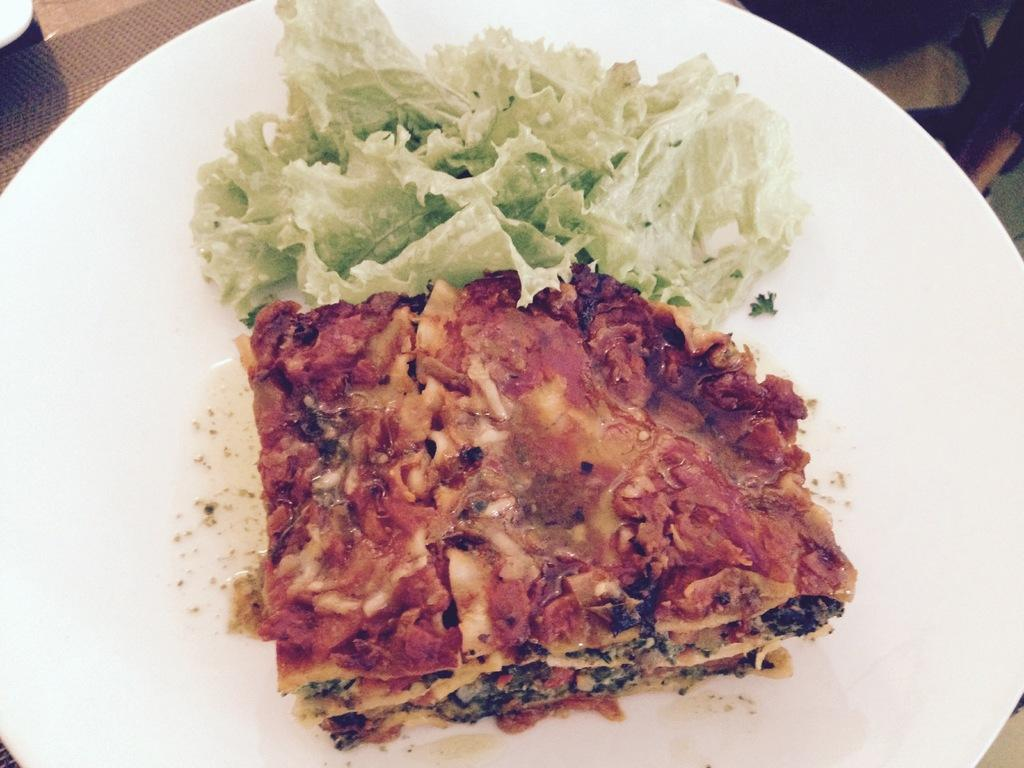What color is the plate that is visible in the image? The plate is white. What is on the plate in the image? There is food on the plate. Where is the plate located in the image? The plate is on a table. What type of furniture is present in the image? There is a chair in the image. What type of spark can be seen coming from the wrench in the image? There is no wrench present in the image, so no spark can be seen. 